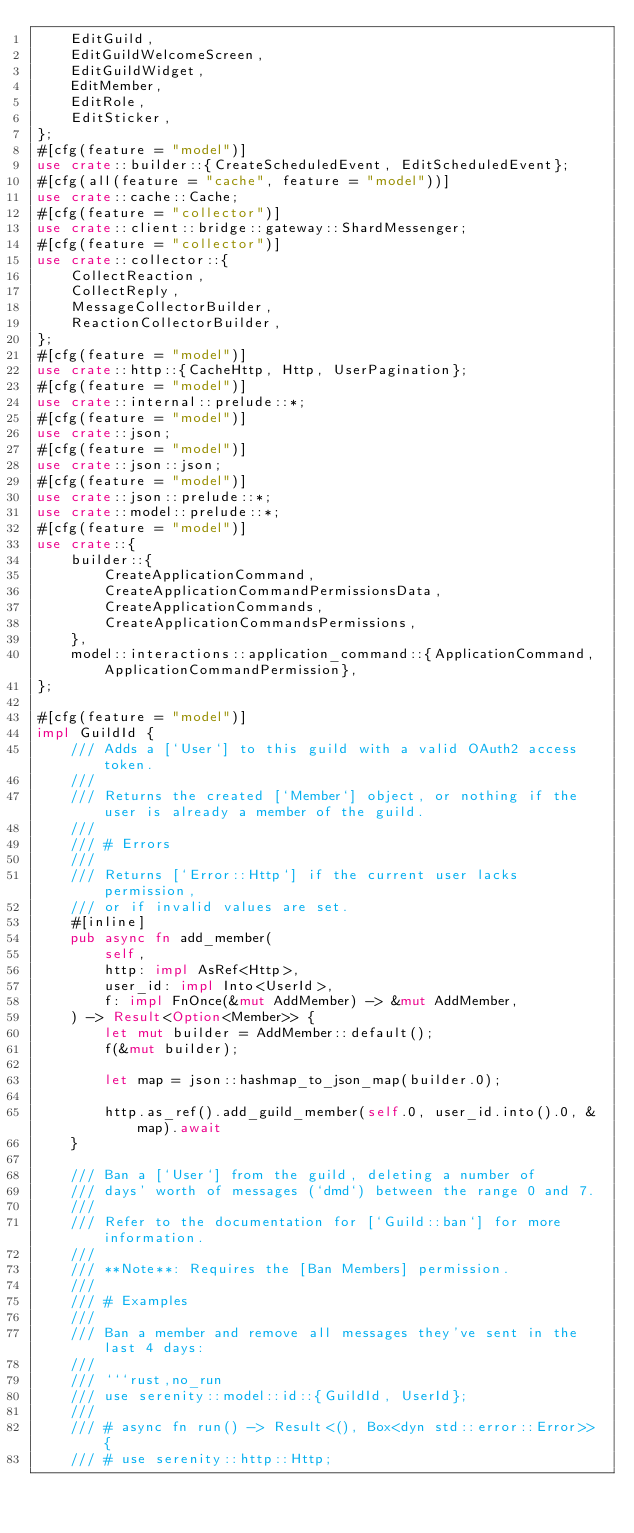<code> <loc_0><loc_0><loc_500><loc_500><_Rust_>    EditGuild,
    EditGuildWelcomeScreen,
    EditGuildWidget,
    EditMember,
    EditRole,
    EditSticker,
};
#[cfg(feature = "model")]
use crate::builder::{CreateScheduledEvent, EditScheduledEvent};
#[cfg(all(feature = "cache", feature = "model"))]
use crate::cache::Cache;
#[cfg(feature = "collector")]
use crate::client::bridge::gateway::ShardMessenger;
#[cfg(feature = "collector")]
use crate::collector::{
    CollectReaction,
    CollectReply,
    MessageCollectorBuilder,
    ReactionCollectorBuilder,
};
#[cfg(feature = "model")]
use crate::http::{CacheHttp, Http, UserPagination};
#[cfg(feature = "model")]
use crate::internal::prelude::*;
#[cfg(feature = "model")]
use crate::json;
#[cfg(feature = "model")]
use crate::json::json;
#[cfg(feature = "model")]
use crate::json::prelude::*;
use crate::model::prelude::*;
#[cfg(feature = "model")]
use crate::{
    builder::{
        CreateApplicationCommand,
        CreateApplicationCommandPermissionsData,
        CreateApplicationCommands,
        CreateApplicationCommandsPermissions,
    },
    model::interactions::application_command::{ApplicationCommand, ApplicationCommandPermission},
};

#[cfg(feature = "model")]
impl GuildId {
    /// Adds a [`User`] to this guild with a valid OAuth2 access token.
    ///
    /// Returns the created [`Member`] object, or nothing if the user is already a member of the guild.
    ///
    /// # Errors
    ///
    /// Returns [`Error::Http`] if the current user lacks permission,
    /// or if invalid values are set.
    #[inline]
    pub async fn add_member(
        self,
        http: impl AsRef<Http>,
        user_id: impl Into<UserId>,
        f: impl FnOnce(&mut AddMember) -> &mut AddMember,
    ) -> Result<Option<Member>> {
        let mut builder = AddMember::default();
        f(&mut builder);

        let map = json::hashmap_to_json_map(builder.0);

        http.as_ref().add_guild_member(self.0, user_id.into().0, &map).await
    }

    /// Ban a [`User`] from the guild, deleting a number of
    /// days' worth of messages (`dmd`) between the range 0 and 7.
    ///
    /// Refer to the documentation for [`Guild::ban`] for more information.
    ///
    /// **Note**: Requires the [Ban Members] permission.
    ///
    /// # Examples
    ///
    /// Ban a member and remove all messages they've sent in the last 4 days:
    ///
    /// ```rust,no_run
    /// use serenity::model::id::{GuildId, UserId};
    ///
    /// # async fn run() -> Result<(), Box<dyn std::error::Error>> {
    /// # use serenity::http::Http;</code> 